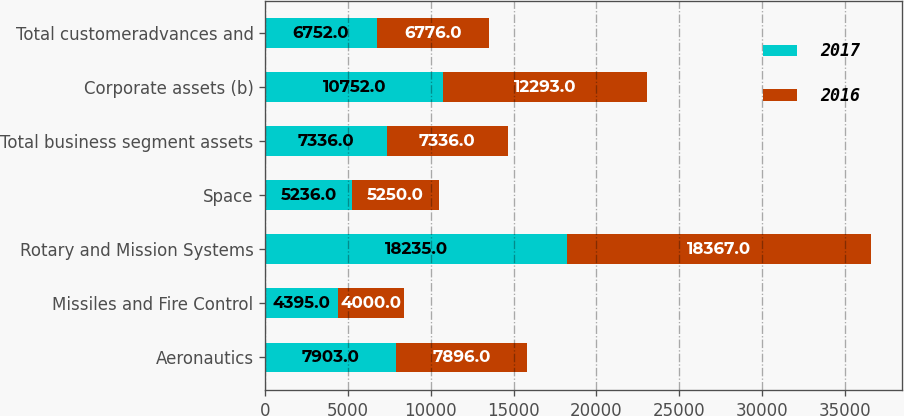Convert chart. <chart><loc_0><loc_0><loc_500><loc_500><stacked_bar_chart><ecel><fcel>Aeronautics<fcel>Missiles and Fire Control<fcel>Rotary and Mission Systems<fcel>Space<fcel>Total business segment assets<fcel>Corporate assets (b)<fcel>Total customeradvances and<nl><fcel>2017<fcel>7903<fcel>4395<fcel>18235<fcel>5236<fcel>7336<fcel>10752<fcel>6752<nl><fcel>2016<fcel>7896<fcel>4000<fcel>18367<fcel>5250<fcel>7336<fcel>12293<fcel>6776<nl></chart> 